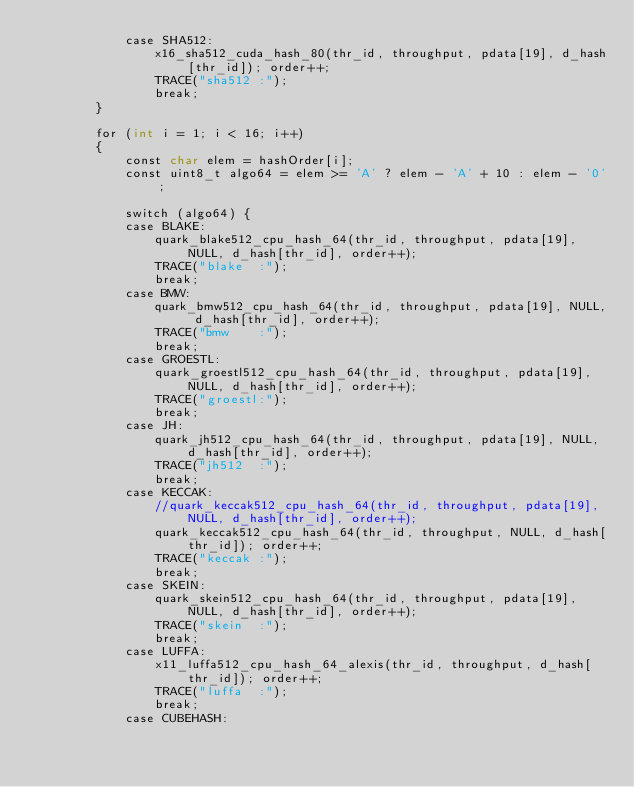<code> <loc_0><loc_0><loc_500><loc_500><_Cuda_>			case SHA512:
				x16_sha512_cuda_hash_80(thr_id, throughput, pdata[19], d_hash[thr_id]); order++;
				TRACE("sha512 :");
				break;
		}

		for (int i = 1; i < 16; i++)
		{
			const char elem = hashOrder[i];
			const uint8_t algo64 = elem >= 'A' ? elem - 'A' + 10 : elem - '0';

			switch (algo64) {
			case BLAKE:
				quark_blake512_cpu_hash_64(thr_id, throughput, pdata[19], NULL, d_hash[thr_id], order++);
				TRACE("blake  :");
				break;
			case BMW:
				quark_bmw512_cpu_hash_64(thr_id, throughput, pdata[19], NULL, d_hash[thr_id], order++);
				TRACE("bmw    :");
				break;
			case GROESTL:
				quark_groestl512_cpu_hash_64(thr_id, throughput, pdata[19], NULL, d_hash[thr_id], order++);
				TRACE("groestl:");
				break;
			case JH:
				quark_jh512_cpu_hash_64(thr_id, throughput, pdata[19], NULL, d_hash[thr_id], order++);
				TRACE("jh512  :");
				break;
			case KECCAK:
				//quark_keccak512_cpu_hash_64(thr_id, throughput, pdata[19], NULL, d_hash[thr_id], order++);
				quark_keccak512_cpu_hash_64(thr_id, throughput, NULL, d_hash[thr_id]); order++;
				TRACE("keccak :");
				break;
			case SKEIN:
				quark_skein512_cpu_hash_64(thr_id, throughput, pdata[19], NULL, d_hash[thr_id], order++);
				TRACE("skein  :");
				break;
			case LUFFA:
				x11_luffa512_cpu_hash_64_alexis(thr_id, throughput, d_hash[thr_id]); order++;
				TRACE("luffa  :");
				break;
			case CUBEHASH:</code> 